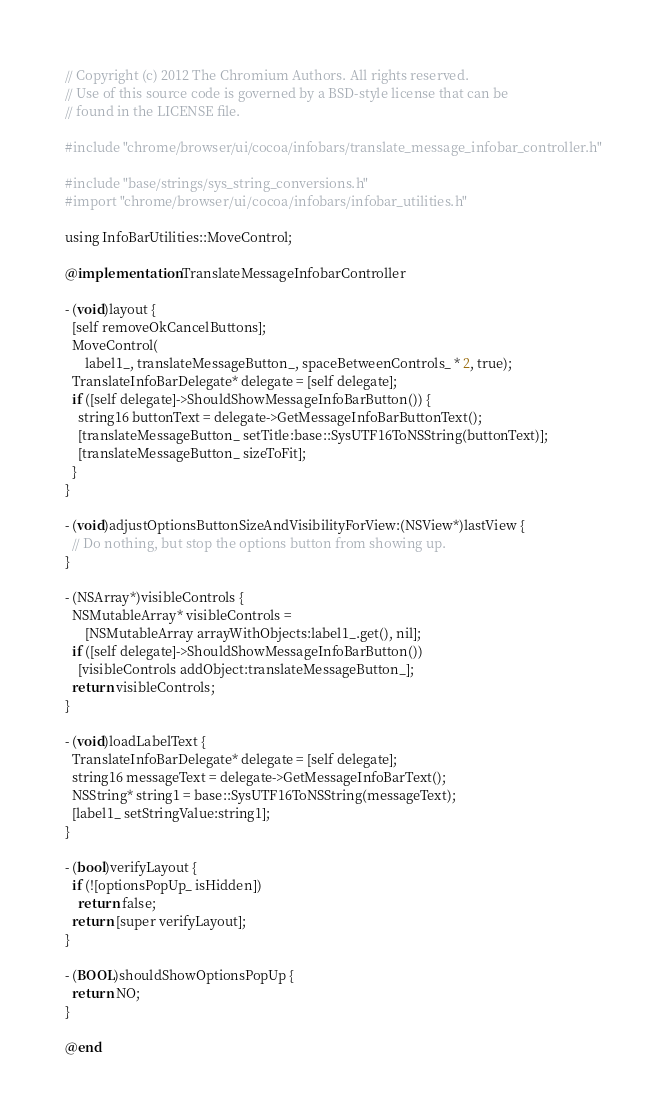Convert code to text. <code><loc_0><loc_0><loc_500><loc_500><_ObjectiveC_>// Copyright (c) 2012 The Chromium Authors. All rights reserved.
// Use of this source code is governed by a BSD-style license that can be
// found in the LICENSE file.

#include "chrome/browser/ui/cocoa/infobars/translate_message_infobar_controller.h"

#include "base/strings/sys_string_conversions.h"
#import "chrome/browser/ui/cocoa/infobars/infobar_utilities.h"

using InfoBarUtilities::MoveControl;

@implementation TranslateMessageInfobarController

- (void)layout {
  [self removeOkCancelButtons];
  MoveControl(
      label1_, translateMessageButton_, spaceBetweenControls_ * 2, true);
  TranslateInfoBarDelegate* delegate = [self delegate];
  if ([self delegate]->ShouldShowMessageInfoBarButton()) {
    string16 buttonText = delegate->GetMessageInfoBarButtonText();
    [translateMessageButton_ setTitle:base::SysUTF16ToNSString(buttonText)];
    [translateMessageButton_ sizeToFit];
  }
}

- (void)adjustOptionsButtonSizeAndVisibilityForView:(NSView*)lastView {
  // Do nothing, but stop the options button from showing up.
}

- (NSArray*)visibleControls {
  NSMutableArray* visibleControls =
      [NSMutableArray arrayWithObjects:label1_.get(), nil];
  if ([self delegate]->ShouldShowMessageInfoBarButton())
    [visibleControls addObject:translateMessageButton_];
  return visibleControls;
}

- (void)loadLabelText {
  TranslateInfoBarDelegate* delegate = [self delegate];
  string16 messageText = delegate->GetMessageInfoBarText();
  NSString* string1 = base::SysUTF16ToNSString(messageText);
  [label1_ setStringValue:string1];
}

- (bool)verifyLayout {
  if (![optionsPopUp_ isHidden])
    return false;
  return [super verifyLayout];
}

- (BOOL)shouldShowOptionsPopUp {
  return NO;
}

@end
</code> 